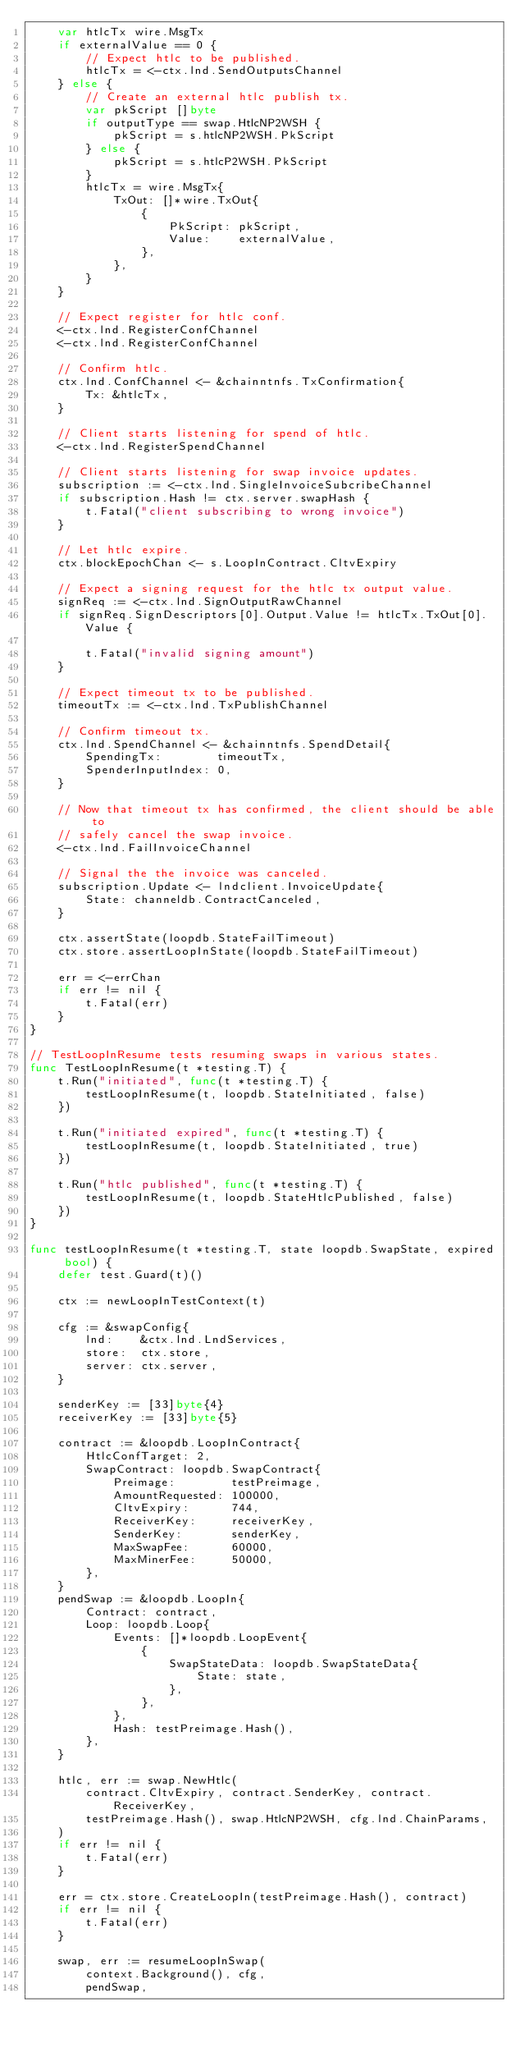Convert code to text. <code><loc_0><loc_0><loc_500><loc_500><_Go_>	var htlcTx wire.MsgTx
	if externalValue == 0 {
		// Expect htlc to be published.
		htlcTx = <-ctx.lnd.SendOutputsChannel
	} else {
		// Create an external htlc publish tx.
		var pkScript []byte
		if outputType == swap.HtlcNP2WSH {
			pkScript = s.htlcNP2WSH.PkScript
		} else {
			pkScript = s.htlcP2WSH.PkScript
		}
		htlcTx = wire.MsgTx{
			TxOut: []*wire.TxOut{
				{
					PkScript: pkScript,
					Value:    externalValue,
				},
			},
		}
	}

	// Expect register for htlc conf.
	<-ctx.lnd.RegisterConfChannel
	<-ctx.lnd.RegisterConfChannel

	// Confirm htlc.
	ctx.lnd.ConfChannel <- &chainntnfs.TxConfirmation{
		Tx: &htlcTx,
	}

	// Client starts listening for spend of htlc.
	<-ctx.lnd.RegisterSpendChannel

	// Client starts listening for swap invoice updates.
	subscription := <-ctx.lnd.SingleInvoiceSubcribeChannel
	if subscription.Hash != ctx.server.swapHash {
		t.Fatal("client subscribing to wrong invoice")
	}

	// Let htlc expire.
	ctx.blockEpochChan <- s.LoopInContract.CltvExpiry

	// Expect a signing request for the htlc tx output value.
	signReq := <-ctx.lnd.SignOutputRawChannel
	if signReq.SignDescriptors[0].Output.Value != htlcTx.TxOut[0].Value {

		t.Fatal("invalid signing amount")
	}

	// Expect timeout tx to be published.
	timeoutTx := <-ctx.lnd.TxPublishChannel

	// Confirm timeout tx.
	ctx.lnd.SpendChannel <- &chainntnfs.SpendDetail{
		SpendingTx:        timeoutTx,
		SpenderInputIndex: 0,
	}

	// Now that timeout tx has confirmed, the client should be able to
	// safely cancel the swap invoice.
	<-ctx.lnd.FailInvoiceChannel

	// Signal the the invoice was canceled.
	subscription.Update <- lndclient.InvoiceUpdate{
		State: channeldb.ContractCanceled,
	}

	ctx.assertState(loopdb.StateFailTimeout)
	ctx.store.assertLoopInState(loopdb.StateFailTimeout)

	err = <-errChan
	if err != nil {
		t.Fatal(err)
	}
}

// TestLoopInResume tests resuming swaps in various states.
func TestLoopInResume(t *testing.T) {
	t.Run("initiated", func(t *testing.T) {
		testLoopInResume(t, loopdb.StateInitiated, false)
	})

	t.Run("initiated expired", func(t *testing.T) {
		testLoopInResume(t, loopdb.StateInitiated, true)
	})

	t.Run("htlc published", func(t *testing.T) {
		testLoopInResume(t, loopdb.StateHtlcPublished, false)
	})
}

func testLoopInResume(t *testing.T, state loopdb.SwapState, expired bool) {
	defer test.Guard(t)()

	ctx := newLoopInTestContext(t)

	cfg := &swapConfig{
		lnd:    &ctx.lnd.LndServices,
		store:  ctx.store,
		server: ctx.server,
	}

	senderKey := [33]byte{4}
	receiverKey := [33]byte{5}

	contract := &loopdb.LoopInContract{
		HtlcConfTarget: 2,
		SwapContract: loopdb.SwapContract{
			Preimage:        testPreimage,
			AmountRequested: 100000,
			CltvExpiry:      744,
			ReceiverKey:     receiverKey,
			SenderKey:       senderKey,
			MaxSwapFee:      60000,
			MaxMinerFee:     50000,
		},
	}
	pendSwap := &loopdb.LoopIn{
		Contract: contract,
		Loop: loopdb.Loop{
			Events: []*loopdb.LoopEvent{
				{
					SwapStateData: loopdb.SwapStateData{
						State: state,
					},
				},
			},
			Hash: testPreimage.Hash(),
		},
	}

	htlc, err := swap.NewHtlc(
		contract.CltvExpiry, contract.SenderKey, contract.ReceiverKey,
		testPreimage.Hash(), swap.HtlcNP2WSH, cfg.lnd.ChainParams,
	)
	if err != nil {
		t.Fatal(err)
	}

	err = ctx.store.CreateLoopIn(testPreimage.Hash(), contract)
	if err != nil {
		t.Fatal(err)
	}

	swap, err := resumeLoopInSwap(
		context.Background(), cfg,
		pendSwap,</code> 